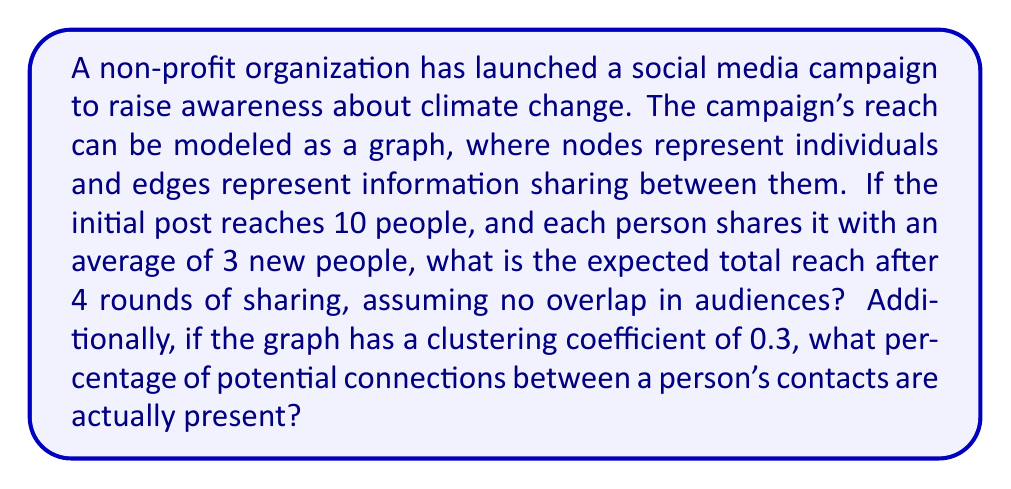Solve this math problem. Let's approach this problem step-by-step:

1. Calculating the total reach:
   - Initial reach: 10 people
   - Each person shares with 3 new people on average
   - We have 4 rounds of sharing

   We can model this as a geometric sequence with:
   $a_1 = 10$ (initial term)
   $r = 3$ (common ratio)
   $n = 5$ (number of terms, including initial reach)

   The sum of a geometric sequence is given by the formula:
   $$S_n = a_1\frac{1-r^n}{1-r}$$

   Substituting our values:
   $$S_5 = 10\frac{1-3^5}{1-3} = 10\frac{1-243}{-2} = 10 \cdot 121 = 1210$$

2. Interpreting the clustering coefficient:
   The clustering coefficient represents the degree to which nodes in a graph tend to cluster together. It's calculated as the ratio of the number of connections between a node's neighbors to the total possible connections.

   A clustering coefficient of 0.3 means that 30% of the potential connections between a person's contacts actually exist.

   To express this as a percentage:
   $0.3 \times 100\% = 30\%$
Answer: 1210 people; 30% 